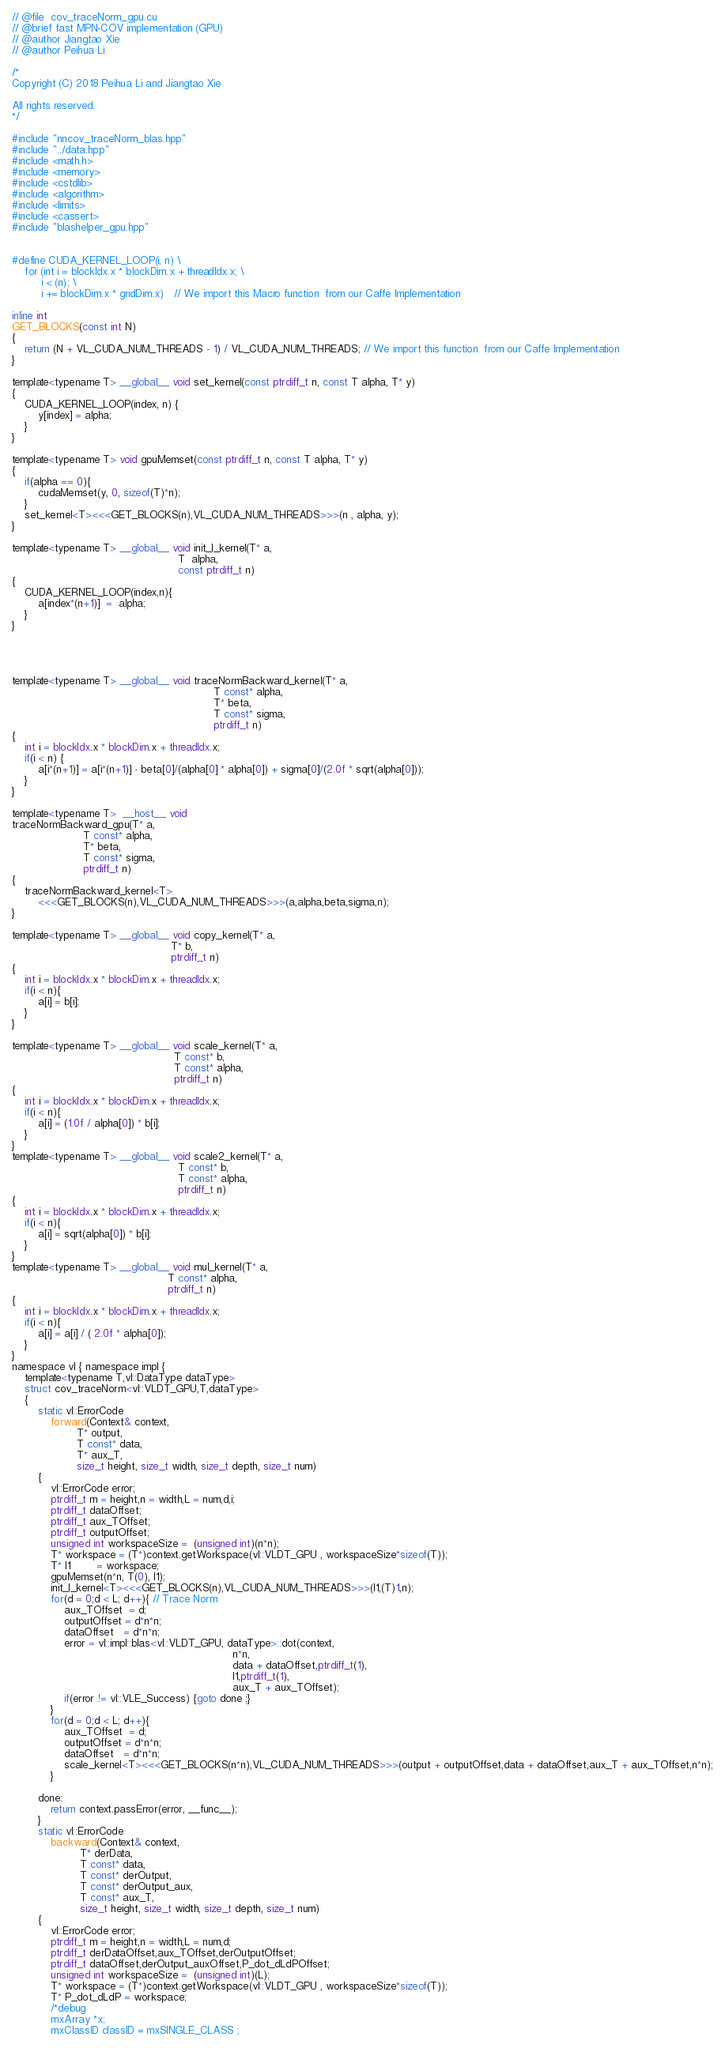Convert code to text. <code><loc_0><loc_0><loc_500><loc_500><_Cuda_>// @file  cov_traceNorm_gpu.cu
// @brief fast MPN-COV implementation (GPU)
// @author Jiangtao Xie
// @author Peihua Li

/*
Copyright (C) 2018 Peihua Li and Jiangtao Xie

All rights reserved.
*/

#include "nncov_traceNorm_blas.hpp"
#include "../data.hpp"
#include <math.h>
#include <memory>
#include <cstdlib>
#include <algorithm>
#include <limits>
#include <cassert>
#include "blashelper_gpu.hpp"


#define CUDA_KERNEL_LOOP(i, n) \
    for (int i = blockIdx.x * blockDim.x + threadIdx.x; \
         i < (n); \
         i += blockDim.x * gridDim.x)   // We import this Macro function  from our Caffe Implementation 

inline int
GET_BLOCKS(const int N)
{
    return (N + VL_CUDA_NUM_THREADS - 1) / VL_CUDA_NUM_THREADS; // We import this function  from our Caffe Implementation 
}

template<typename T> __global__ void set_kernel(const ptrdiff_t n, const T alpha, T* y) 
{
    CUDA_KERNEL_LOOP(index, n) {
        y[index] = alpha;
    }
}

template<typename T> void gpuMemset(const ptrdiff_t n, const T alpha, T* y)
{
    if(alpha == 0){
        cudaMemset(y, 0, sizeof(T)*n);
    }
    set_kernel<T><<<GET_BLOCKS(n),VL_CUDA_NUM_THREADS>>>(n , alpha, y);
}

template<typename T> __global__ void init_I_kernel(T* a,
                                                   T  alpha,
                                                   const ptrdiff_t n)
{
    CUDA_KERNEL_LOOP(index,n){
        a[index*(n+1)]  =  alpha;
    }
}




template<typename T> __global__ void traceNormBackward_kernel(T* a,
                                                              T const* alpha,
                                                              T* beta,
                                                              T const* sigma,
                                                              ptrdiff_t n)
{
    int i = blockIdx.x * blockDim.x + threadIdx.x;
    if(i < n) {
        a[i*(n+1)] = a[i*(n+1)] - beta[0]/(alpha[0] * alpha[0]) + sigma[0]/(2.0f * sqrt(alpha[0]));
    }
}

template<typename T>  __host__ void
traceNormBackward_gpu(T* a,
                      T const* alpha,
                      T* beta,
                      T const* sigma,
                      ptrdiff_t n)
{
    traceNormBackward_kernel<T>
        <<<GET_BLOCKS(n),VL_CUDA_NUM_THREADS>>>(a,alpha,beta,sigma,n);
}

template<typename T> __global__ void copy_kernel(T* a,
                                                 T* b,
                                                 ptrdiff_t n)
{
    int i = blockIdx.x * blockDim.x + threadIdx.x;
    if(i < n){
        a[i] = b[i];
    }
}

template<typename T> __global__ void scale_kernel(T* a,
                                                  T const* b,
                                                  T const* alpha,
                                                  ptrdiff_t n)
{
    int i = blockIdx.x * blockDim.x + threadIdx.x;
    if(i < n){
        a[i] = (1.0f / alpha[0]) * b[i];
    }
}
template<typename T> __global__ void scale2_kernel(T* a,
                                                   T const* b,
                                                   T const* alpha,
                                                   ptrdiff_t n)
{
    int i = blockIdx.x * blockDim.x + threadIdx.x;
    if(i < n){
        a[i] = sqrt(alpha[0]) * b[i];
    }
}
template<typename T> __global__ void mul_kernel(T* a,
                                                T const* alpha,
                                                ptrdiff_t n)
{
    int i = blockIdx.x * blockDim.x + threadIdx.x;
    if(i < n){
        a[i] = a[i] / ( 2.0f * alpha[0]);
    }
}
namespace vl { namespace impl {
    template<typename T,vl::DataType dataType>
    struct cov_traceNorm<vl::VLDT_GPU,T,dataType>
    {
        static vl::ErrorCode
            forward(Context& context,
                    T* output,
                    T const* data,
                    T* aux_T,
                    size_t height, size_t width, size_t depth, size_t num)
        {
            vl::ErrorCode error;
            ptrdiff_t m = height,n = width,L = num,d,i;
            ptrdiff_t dataOffset;
            ptrdiff_t aux_TOffset;
            ptrdiff_t outputOffset;
            unsigned int workspaceSize =  (unsigned int)(n*n);
            T* workspace = (T*)context.getWorkspace(vl::VLDT_GPU , workspaceSize*sizeof(T));
            T* I1        = workspace;
            gpuMemset(n*n, T(0), I1);
            init_I_kernel<T><<<GET_BLOCKS(n),VL_CUDA_NUM_THREADS>>>(I1,(T)1,n);
            for(d = 0;d < L; d++){ // Trace Norm
                aux_TOffset  = d;
                outputOffset = d*n*n;
                dataOffset   = d*n*n;
                error = vl::impl::blas<vl::VLDT_GPU, dataType>::dot(context,
                                                                    n*n,
                                                                    data + dataOffset,ptrdiff_t(1),
                                                                    I1,ptrdiff_t(1),
                                                                    aux_T + aux_TOffset);
                if(error != vl::VLE_Success) {goto done ;}
            }
            for(d = 0;d < L; d++){
                aux_TOffset  = d;
                outputOffset = d*n*n;
                dataOffset   = d*n*n;
                scale_kernel<T><<<GET_BLOCKS(n*n),VL_CUDA_NUM_THREADS>>>(output + outputOffset,data + dataOffset,aux_T + aux_TOffset,n*n);
            }
            
        done:
            return context.passError(error, __func__);
        }
        static vl::ErrorCode
            backward(Context& context,
                     T* derData,
                     T const* data,
                     T const* derOutput,
                     T const* derOutput_aux,
                     T const* aux_T,
                     size_t height, size_t width, size_t depth, size_t num)
        {
            vl::ErrorCode error;
            ptrdiff_t m = height,n = width,L = num,d;
            ptrdiff_t derDataOffset,aux_TOffset,derOutputOffset;
            ptrdiff_t dataOffset,derOutput_auxOffset,P_dot_dLdPOffset;
            unsigned int workspaceSize =  (unsigned int)(L);
            T* workspace = (T*)context.getWorkspace(vl::VLDT_GPU , workspaceSize*sizeof(T));
            T* P_dot_dLdP = workspace;
            /*debug
            mxArray *x;
            mxClassID classID = mxSINGLE_CLASS ;</code> 